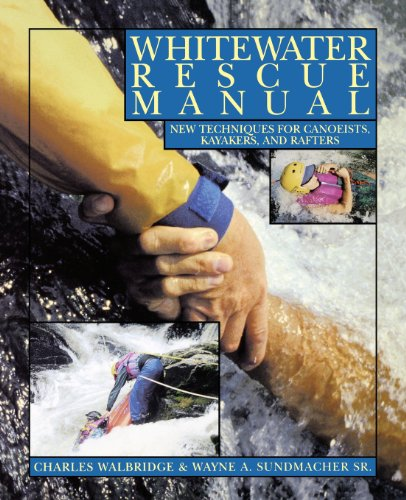How can this book benefit individuals interested in water sports? This manual provides valuable safety and rescue techniques that are crucial for anyone involved in canoeing, kayaking, and rafting. It aims to enhance the reader's knowledge and preparedness for handling emergencies effectively, making water sports safer and more enjoyable. 